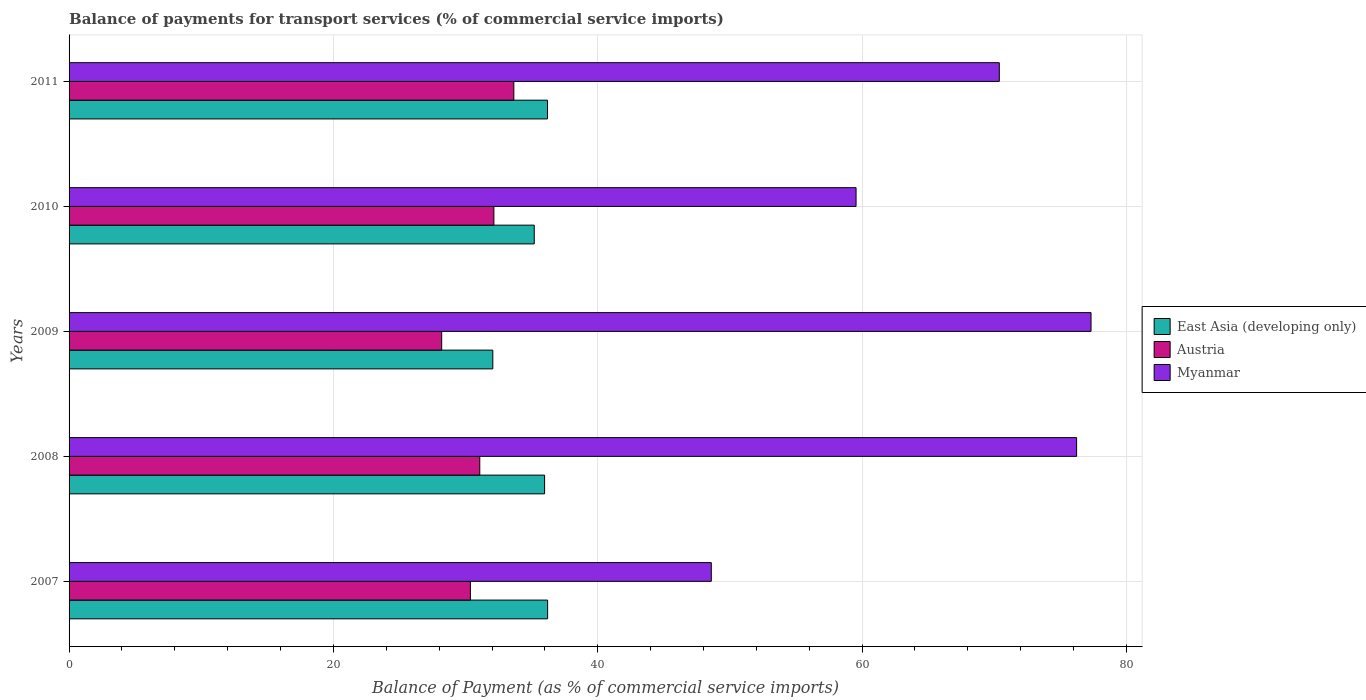How many different coloured bars are there?
Offer a very short reply. 3. Are the number of bars on each tick of the Y-axis equal?
Your response must be concise. Yes. How many bars are there on the 5th tick from the top?
Provide a short and direct response. 3. In how many cases, is the number of bars for a given year not equal to the number of legend labels?
Keep it short and to the point. 0. What is the balance of payments for transport services in Myanmar in 2008?
Give a very brief answer. 76.23. Across all years, what is the maximum balance of payments for transport services in East Asia (developing only)?
Your answer should be compact. 36.21. Across all years, what is the minimum balance of payments for transport services in Austria?
Provide a short and direct response. 28.19. In which year was the balance of payments for transport services in Myanmar maximum?
Keep it short and to the point. 2009. What is the total balance of payments for transport services in Austria in the graph?
Keep it short and to the point. 155.43. What is the difference between the balance of payments for transport services in East Asia (developing only) in 2008 and that in 2009?
Your response must be concise. 3.92. What is the difference between the balance of payments for transport services in East Asia (developing only) in 2010 and the balance of payments for transport services in Austria in 2009?
Provide a short and direct response. 7. What is the average balance of payments for transport services in Myanmar per year?
Provide a succinct answer. 66.42. In the year 2008, what is the difference between the balance of payments for transport services in Austria and balance of payments for transport services in East Asia (developing only)?
Your answer should be very brief. -4.9. In how many years, is the balance of payments for transport services in Austria greater than 8 %?
Your answer should be very brief. 5. What is the ratio of the balance of payments for transport services in East Asia (developing only) in 2009 to that in 2011?
Offer a terse response. 0.89. Is the balance of payments for transport services in East Asia (developing only) in 2007 less than that in 2009?
Ensure brevity in your answer.  No. What is the difference between the highest and the second highest balance of payments for transport services in Austria?
Offer a very short reply. 1.51. What is the difference between the highest and the lowest balance of payments for transport services in Myanmar?
Make the answer very short. 28.73. In how many years, is the balance of payments for transport services in Myanmar greater than the average balance of payments for transport services in Myanmar taken over all years?
Provide a succinct answer. 3. Is it the case that in every year, the sum of the balance of payments for transport services in East Asia (developing only) and balance of payments for transport services in Myanmar is greater than the balance of payments for transport services in Austria?
Offer a terse response. Yes. How many bars are there?
Make the answer very short. 15. Are all the bars in the graph horizontal?
Your response must be concise. Yes. How many years are there in the graph?
Your answer should be very brief. 5. What is the difference between two consecutive major ticks on the X-axis?
Provide a succinct answer. 20. What is the title of the graph?
Provide a succinct answer. Balance of payments for transport services (% of commercial service imports). Does "Kyrgyz Republic" appear as one of the legend labels in the graph?
Ensure brevity in your answer.  No. What is the label or title of the X-axis?
Ensure brevity in your answer.  Balance of Payment (as % of commercial service imports). What is the Balance of Payment (as % of commercial service imports) in East Asia (developing only) in 2007?
Your response must be concise. 36.21. What is the Balance of Payment (as % of commercial service imports) of Austria in 2007?
Offer a terse response. 30.37. What is the Balance of Payment (as % of commercial service imports) of Myanmar in 2007?
Your response must be concise. 48.59. What is the Balance of Payment (as % of commercial service imports) in East Asia (developing only) in 2008?
Ensure brevity in your answer.  35.98. What is the Balance of Payment (as % of commercial service imports) of Austria in 2008?
Your response must be concise. 31.08. What is the Balance of Payment (as % of commercial service imports) of Myanmar in 2008?
Provide a succinct answer. 76.23. What is the Balance of Payment (as % of commercial service imports) of East Asia (developing only) in 2009?
Give a very brief answer. 32.06. What is the Balance of Payment (as % of commercial service imports) of Austria in 2009?
Make the answer very short. 28.19. What is the Balance of Payment (as % of commercial service imports) of Myanmar in 2009?
Offer a very short reply. 77.32. What is the Balance of Payment (as % of commercial service imports) in East Asia (developing only) in 2010?
Ensure brevity in your answer.  35.2. What is the Balance of Payment (as % of commercial service imports) in Austria in 2010?
Ensure brevity in your answer.  32.14. What is the Balance of Payment (as % of commercial service imports) of Myanmar in 2010?
Offer a very short reply. 59.55. What is the Balance of Payment (as % of commercial service imports) of East Asia (developing only) in 2011?
Give a very brief answer. 36.2. What is the Balance of Payment (as % of commercial service imports) in Austria in 2011?
Offer a very short reply. 33.65. What is the Balance of Payment (as % of commercial service imports) in Myanmar in 2011?
Keep it short and to the point. 70.38. Across all years, what is the maximum Balance of Payment (as % of commercial service imports) of East Asia (developing only)?
Ensure brevity in your answer.  36.21. Across all years, what is the maximum Balance of Payment (as % of commercial service imports) in Austria?
Your answer should be very brief. 33.65. Across all years, what is the maximum Balance of Payment (as % of commercial service imports) in Myanmar?
Your answer should be compact. 77.32. Across all years, what is the minimum Balance of Payment (as % of commercial service imports) in East Asia (developing only)?
Your answer should be compact. 32.06. Across all years, what is the minimum Balance of Payment (as % of commercial service imports) in Austria?
Offer a very short reply. 28.19. Across all years, what is the minimum Balance of Payment (as % of commercial service imports) in Myanmar?
Your response must be concise. 48.59. What is the total Balance of Payment (as % of commercial service imports) in East Asia (developing only) in the graph?
Provide a succinct answer. 175.65. What is the total Balance of Payment (as % of commercial service imports) of Austria in the graph?
Your answer should be very brief. 155.43. What is the total Balance of Payment (as % of commercial service imports) of Myanmar in the graph?
Make the answer very short. 332.08. What is the difference between the Balance of Payment (as % of commercial service imports) in East Asia (developing only) in 2007 and that in 2008?
Keep it short and to the point. 0.23. What is the difference between the Balance of Payment (as % of commercial service imports) in Austria in 2007 and that in 2008?
Offer a very short reply. -0.71. What is the difference between the Balance of Payment (as % of commercial service imports) of Myanmar in 2007 and that in 2008?
Your response must be concise. -27.64. What is the difference between the Balance of Payment (as % of commercial service imports) in East Asia (developing only) in 2007 and that in 2009?
Provide a short and direct response. 4.15. What is the difference between the Balance of Payment (as % of commercial service imports) of Austria in 2007 and that in 2009?
Make the answer very short. 2.17. What is the difference between the Balance of Payment (as % of commercial service imports) of Myanmar in 2007 and that in 2009?
Offer a terse response. -28.73. What is the difference between the Balance of Payment (as % of commercial service imports) in East Asia (developing only) in 2007 and that in 2010?
Make the answer very short. 1.01. What is the difference between the Balance of Payment (as % of commercial service imports) of Austria in 2007 and that in 2010?
Offer a very short reply. -1.78. What is the difference between the Balance of Payment (as % of commercial service imports) of Myanmar in 2007 and that in 2010?
Your answer should be compact. -10.95. What is the difference between the Balance of Payment (as % of commercial service imports) of East Asia (developing only) in 2007 and that in 2011?
Offer a very short reply. 0.01. What is the difference between the Balance of Payment (as % of commercial service imports) in Austria in 2007 and that in 2011?
Provide a short and direct response. -3.29. What is the difference between the Balance of Payment (as % of commercial service imports) in Myanmar in 2007 and that in 2011?
Give a very brief answer. -21.79. What is the difference between the Balance of Payment (as % of commercial service imports) of East Asia (developing only) in 2008 and that in 2009?
Give a very brief answer. 3.92. What is the difference between the Balance of Payment (as % of commercial service imports) in Austria in 2008 and that in 2009?
Provide a succinct answer. 2.88. What is the difference between the Balance of Payment (as % of commercial service imports) in Myanmar in 2008 and that in 2009?
Give a very brief answer. -1.09. What is the difference between the Balance of Payment (as % of commercial service imports) in East Asia (developing only) in 2008 and that in 2010?
Provide a short and direct response. 0.78. What is the difference between the Balance of Payment (as % of commercial service imports) of Austria in 2008 and that in 2010?
Your response must be concise. -1.07. What is the difference between the Balance of Payment (as % of commercial service imports) of Myanmar in 2008 and that in 2010?
Give a very brief answer. 16.69. What is the difference between the Balance of Payment (as % of commercial service imports) in East Asia (developing only) in 2008 and that in 2011?
Ensure brevity in your answer.  -0.22. What is the difference between the Balance of Payment (as % of commercial service imports) of Austria in 2008 and that in 2011?
Provide a succinct answer. -2.58. What is the difference between the Balance of Payment (as % of commercial service imports) of Myanmar in 2008 and that in 2011?
Offer a very short reply. 5.85. What is the difference between the Balance of Payment (as % of commercial service imports) in East Asia (developing only) in 2009 and that in 2010?
Your response must be concise. -3.13. What is the difference between the Balance of Payment (as % of commercial service imports) in Austria in 2009 and that in 2010?
Offer a terse response. -3.95. What is the difference between the Balance of Payment (as % of commercial service imports) of Myanmar in 2009 and that in 2010?
Your answer should be very brief. 17.78. What is the difference between the Balance of Payment (as % of commercial service imports) in East Asia (developing only) in 2009 and that in 2011?
Your answer should be compact. -4.14. What is the difference between the Balance of Payment (as % of commercial service imports) in Austria in 2009 and that in 2011?
Provide a short and direct response. -5.46. What is the difference between the Balance of Payment (as % of commercial service imports) of Myanmar in 2009 and that in 2011?
Your answer should be compact. 6.94. What is the difference between the Balance of Payment (as % of commercial service imports) in East Asia (developing only) in 2010 and that in 2011?
Provide a succinct answer. -1. What is the difference between the Balance of Payment (as % of commercial service imports) of Austria in 2010 and that in 2011?
Give a very brief answer. -1.51. What is the difference between the Balance of Payment (as % of commercial service imports) in Myanmar in 2010 and that in 2011?
Ensure brevity in your answer.  -10.84. What is the difference between the Balance of Payment (as % of commercial service imports) in East Asia (developing only) in 2007 and the Balance of Payment (as % of commercial service imports) in Austria in 2008?
Your answer should be compact. 5.13. What is the difference between the Balance of Payment (as % of commercial service imports) of East Asia (developing only) in 2007 and the Balance of Payment (as % of commercial service imports) of Myanmar in 2008?
Give a very brief answer. -40.02. What is the difference between the Balance of Payment (as % of commercial service imports) of Austria in 2007 and the Balance of Payment (as % of commercial service imports) of Myanmar in 2008?
Your answer should be very brief. -45.87. What is the difference between the Balance of Payment (as % of commercial service imports) in East Asia (developing only) in 2007 and the Balance of Payment (as % of commercial service imports) in Austria in 2009?
Keep it short and to the point. 8.02. What is the difference between the Balance of Payment (as % of commercial service imports) in East Asia (developing only) in 2007 and the Balance of Payment (as % of commercial service imports) in Myanmar in 2009?
Give a very brief answer. -41.12. What is the difference between the Balance of Payment (as % of commercial service imports) of Austria in 2007 and the Balance of Payment (as % of commercial service imports) of Myanmar in 2009?
Keep it short and to the point. -46.96. What is the difference between the Balance of Payment (as % of commercial service imports) of East Asia (developing only) in 2007 and the Balance of Payment (as % of commercial service imports) of Austria in 2010?
Provide a short and direct response. 4.07. What is the difference between the Balance of Payment (as % of commercial service imports) in East Asia (developing only) in 2007 and the Balance of Payment (as % of commercial service imports) in Myanmar in 2010?
Your response must be concise. -23.34. What is the difference between the Balance of Payment (as % of commercial service imports) of Austria in 2007 and the Balance of Payment (as % of commercial service imports) of Myanmar in 2010?
Provide a short and direct response. -29.18. What is the difference between the Balance of Payment (as % of commercial service imports) of East Asia (developing only) in 2007 and the Balance of Payment (as % of commercial service imports) of Austria in 2011?
Your answer should be very brief. 2.56. What is the difference between the Balance of Payment (as % of commercial service imports) in East Asia (developing only) in 2007 and the Balance of Payment (as % of commercial service imports) in Myanmar in 2011?
Provide a short and direct response. -34.18. What is the difference between the Balance of Payment (as % of commercial service imports) of Austria in 2007 and the Balance of Payment (as % of commercial service imports) of Myanmar in 2011?
Offer a very short reply. -40.02. What is the difference between the Balance of Payment (as % of commercial service imports) of East Asia (developing only) in 2008 and the Balance of Payment (as % of commercial service imports) of Austria in 2009?
Make the answer very short. 7.79. What is the difference between the Balance of Payment (as % of commercial service imports) in East Asia (developing only) in 2008 and the Balance of Payment (as % of commercial service imports) in Myanmar in 2009?
Give a very brief answer. -41.35. What is the difference between the Balance of Payment (as % of commercial service imports) of Austria in 2008 and the Balance of Payment (as % of commercial service imports) of Myanmar in 2009?
Ensure brevity in your answer.  -46.25. What is the difference between the Balance of Payment (as % of commercial service imports) in East Asia (developing only) in 2008 and the Balance of Payment (as % of commercial service imports) in Austria in 2010?
Your answer should be compact. 3.84. What is the difference between the Balance of Payment (as % of commercial service imports) in East Asia (developing only) in 2008 and the Balance of Payment (as % of commercial service imports) in Myanmar in 2010?
Provide a succinct answer. -23.57. What is the difference between the Balance of Payment (as % of commercial service imports) of Austria in 2008 and the Balance of Payment (as % of commercial service imports) of Myanmar in 2010?
Keep it short and to the point. -28.47. What is the difference between the Balance of Payment (as % of commercial service imports) in East Asia (developing only) in 2008 and the Balance of Payment (as % of commercial service imports) in Austria in 2011?
Provide a succinct answer. 2.33. What is the difference between the Balance of Payment (as % of commercial service imports) of East Asia (developing only) in 2008 and the Balance of Payment (as % of commercial service imports) of Myanmar in 2011?
Provide a succinct answer. -34.4. What is the difference between the Balance of Payment (as % of commercial service imports) in Austria in 2008 and the Balance of Payment (as % of commercial service imports) in Myanmar in 2011?
Keep it short and to the point. -39.31. What is the difference between the Balance of Payment (as % of commercial service imports) of East Asia (developing only) in 2009 and the Balance of Payment (as % of commercial service imports) of Austria in 2010?
Give a very brief answer. -0.08. What is the difference between the Balance of Payment (as % of commercial service imports) in East Asia (developing only) in 2009 and the Balance of Payment (as % of commercial service imports) in Myanmar in 2010?
Offer a terse response. -27.48. What is the difference between the Balance of Payment (as % of commercial service imports) in Austria in 2009 and the Balance of Payment (as % of commercial service imports) in Myanmar in 2010?
Your response must be concise. -31.35. What is the difference between the Balance of Payment (as % of commercial service imports) in East Asia (developing only) in 2009 and the Balance of Payment (as % of commercial service imports) in Austria in 2011?
Provide a succinct answer. -1.59. What is the difference between the Balance of Payment (as % of commercial service imports) in East Asia (developing only) in 2009 and the Balance of Payment (as % of commercial service imports) in Myanmar in 2011?
Provide a succinct answer. -38.32. What is the difference between the Balance of Payment (as % of commercial service imports) in Austria in 2009 and the Balance of Payment (as % of commercial service imports) in Myanmar in 2011?
Provide a succinct answer. -42.19. What is the difference between the Balance of Payment (as % of commercial service imports) of East Asia (developing only) in 2010 and the Balance of Payment (as % of commercial service imports) of Austria in 2011?
Offer a very short reply. 1.55. What is the difference between the Balance of Payment (as % of commercial service imports) of East Asia (developing only) in 2010 and the Balance of Payment (as % of commercial service imports) of Myanmar in 2011?
Offer a terse response. -35.19. What is the difference between the Balance of Payment (as % of commercial service imports) of Austria in 2010 and the Balance of Payment (as % of commercial service imports) of Myanmar in 2011?
Make the answer very short. -38.24. What is the average Balance of Payment (as % of commercial service imports) of East Asia (developing only) per year?
Your answer should be compact. 35.13. What is the average Balance of Payment (as % of commercial service imports) in Austria per year?
Keep it short and to the point. 31.09. What is the average Balance of Payment (as % of commercial service imports) of Myanmar per year?
Make the answer very short. 66.42. In the year 2007, what is the difference between the Balance of Payment (as % of commercial service imports) in East Asia (developing only) and Balance of Payment (as % of commercial service imports) in Austria?
Offer a terse response. 5.84. In the year 2007, what is the difference between the Balance of Payment (as % of commercial service imports) of East Asia (developing only) and Balance of Payment (as % of commercial service imports) of Myanmar?
Your response must be concise. -12.38. In the year 2007, what is the difference between the Balance of Payment (as % of commercial service imports) in Austria and Balance of Payment (as % of commercial service imports) in Myanmar?
Ensure brevity in your answer.  -18.23. In the year 2008, what is the difference between the Balance of Payment (as % of commercial service imports) of East Asia (developing only) and Balance of Payment (as % of commercial service imports) of Austria?
Your answer should be very brief. 4.9. In the year 2008, what is the difference between the Balance of Payment (as % of commercial service imports) of East Asia (developing only) and Balance of Payment (as % of commercial service imports) of Myanmar?
Keep it short and to the point. -40.25. In the year 2008, what is the difference between the Balance of Payment (as % of commercial service imports) in Austria and Balance of Payment (as % of commercial service imports) in Myanmar?
Make the answer very short. -45.16. In the year 2009, what is the difference between the Balance of Payment (as % of commercial service imports) of East Asia (developing only) and Balance of Payment (as % of commercial service imports) of Austria?
Your answer should be compact. 3.87. In the year 2009, what is the difference between the Balance of Payment (as % of commercial service imports) of East Asia (developing only) and Balance of Payment (as % of commercial service imports) of Myanmar?
Offer a terse response. -45.26. In the year 2009, what is the difference between the Balance of Payment (as % of commercial service imports) in Austria and Balance of Payment (as % of commercial service imports) in Myanmar?
Provide a succinct answer. -49.13. In the year 2010, what is the difference between the Balance of Payment (as % of commercial service imports) of East Asia (developing only) and Balance of Payment (as % of commercial service imports) of Austria?
Ensure brevity in your answer.  3.05. In the year 2010, what is the difference between the Balance of Payment (as % of commercial service imports) in East Asia (developing only) and Balance of Payment (as % of commercial service imports) in Myanmar?
Offer a very short reply. -24.35. In the year 2010, what is the difference between the Balance of Payment (as % of commercial service imports) in Austria and Balance of Payment (as % of commercial service imports) in Myanmar?
Your answer should be compact. -27.4. In the year 2011, what is the difference between the Balance of Payment (as % of commercial service imports) in East Asia (developing only) and Balance of Payment (as % of commercial service imports) in Austria?
Ensure brevity in your answer.  2.55. In the year 2011, what is the difference between the Balance of Payment (as % of commercial service imports) in East Asia (developing only) and Balance of Payment (as % of commercial service imports) in Myanmar?
Your response must be concise. -34.18. In the year 2011, what is the difference between the Balance of Payment (as % of commercial service imports) in Austria and Balance of Payment (as % of commercial service imports) in Myanmar?
Provide a short and direct response. -36.73. What is the ratio of the Balance of Payment (as % of commercial service imports) of East Asia (developing only) in 2007 to that in 2008?
Your answer should be very brief. 1.01. What is the ratio of the Balance of Payment (as % of commercial service imports) of Austria in 2007 to that in 2008?
Offer a very short reply. 0.98. What is the ratio of the Balance of Payment (as % of commercial service imports) of Myanmar in 2007 to that in 2008?
Offer a very short reply. 0.64. What is the ratio of the Balance of Payment (as % of commercial service imports) of East Asia (developing only) in 2007 to that in 2009?
Your response must be concise. 1.13. What is the ratio of the Balance of Payment (as % of commercial service imports) in Austria in 2007 to that in 2009?
Provide a succinct answer. 1.08. What is the ratio of the Balance of Payment (as % of commercial service imports) in Myanmar in 2007 to that in 2009?
Your response must be concise. 0.63. What is the ratio of the Balance of Payment (as % of commercial service imports) of East Asia (developing only) in 2007 to that in 2010?
Offer a very short reply. 1.03. What is the ratio of the Balance of Payment (as % of commercial service imports) in Austria in 2007 to that in 2010?
Your answer should be compact. 0.94. What is the ratio of the Balance of Payment (as % of commercial service imports) in Myanmar in 2007 to that in 2010?
Your answer should be very brief. 0.82. What is the ratio of the Balance of Payment (as % of commercial service imports) of Austria in 2007 to that in 2011?
Your answer should be very brief. 0.9. What is the ratio of the Balance of Payment (as % of commercial service imports) in Myanmar in 2007 to that in 2011?
Your answer should be compact. 0.69. What is the ratio of the Balance of Payment (as % of commercial service imports) in East Asia (developing only) in 2008 to that in 2009?
Offer a very short reply. 1.12. What is the ratio of the Balance of Payment (as % of commercial service imports) of Austria in 2008 to that in 2009?
Keep it short and to the point. 1.1. What is the ratio of the Balance of Payment (as % of commercial service imports) in Myanmar in 2008 to that in 2009?
Provide a short and direct response. 0.99. What is the ratio of the Balance of Payment (as % of commercial service imports) in East Asia (developing only) in 2008 to that in 2010?
Offer a terse response. 1.02. What is the ratio of the Balance of Payment (as % of commercial service imports) in Austria in 2008 to that in 2010?
Offer a terse response. 0.97. What is the ratio of the Balance of Payment (as % of commercial service imports) in Myanmar in 2008 to that in 2010?
Provide a succinct answer. 1.28. What is the ratio of the Balance of Payment (as % of commercial service imports) of East Asia (developing only) in 2008 to that in 2011?
Your response must be concise. 0.99. What is the ratio of the Balance of Payment (as % of commercial service imports) of Austria in 2008 to that in 2011?
Ensure brevity in your answer.  0.92. What is the ratio of the Balance of Payment (as % of commercial service imports) in Myanmar in 2008 to that in 2011?
Your answer should be compact. 1.08. What is the ratio of the Balance of Payment (as % of commercial service imports) in East Asia (developing only) in 2009 to that in 2010?
Give a very brief answer. 0.91. What is the ratio of the Balance of Payment (as % of commercial service imports) in Austria in 2009 to that in 2010?
Offer a very short reply. 0.88. What is the ratio of the Balance of Payment (as % of commercial service imports) in Myanmar in 2009 to that in 2010?
Ensure brevity in your answer.  1.3. What is the ratio of the Balance of Payment (as % of commercial service imports) of East Asia (developing only) in 2009 to that in 2011?
Keep it short and to the point. 0.89. What is the ratio of the Balance of Payment (as % of commercial service imports) in Austria in 2009 to that in 2011?
Your answer should be very brief. 0.84. What is the ratio of the Balance of Payment (as % of commercial service imports) of Myanmar in 2009 to that in 2011?
Ensure brevity in your answer.  1.1. What is the ratio of the Balance of Payment (as % of commercial service imports) of East Asia (developing only) in 2010 to that in 2011?
Your answer should be compact. 0.97. What is the ratio of the Balance of Payment (as % of commercial service imports) of Austria in 2010 to that in 2011?
Make the answer very short. 0.96. What is the ratio of the Balance of Payment (as % of commercial service imports) of Myanmar in 2010 to that in 2011?
Your answer should be very brief. 0.85. What is the difference between the highest and the second highest Balance of Payment (as % of commercial service imports) of East Asia (developing only)?
Provide a short and direct response. 0.01. What is the difference between the highest and the second highest Balance of Payment (as % of commercial service imports) of Austria?
Keep it short and to the point. 1.51. What is the difference between the highest and the second highest Balance of Payment (as % of commercial service imports) in Myanmar?
Make the answer very short. 1.09. What is the difference between the highest and the lowest Balance of Payment (as % of commercial service imports) of East Asia (developing only)?
Ensure brevity in your answer.  4.15. What is the difference between the highest and the lowest Balance of Payment (as % of commercial service imports) of Austria?
Provide a short and direct response. 5.46. What is the difference between the highest and the lowest Balance of Payment (as % of commercial service imports) in Myanmar?
Keep it short and to the point. 28.73. 